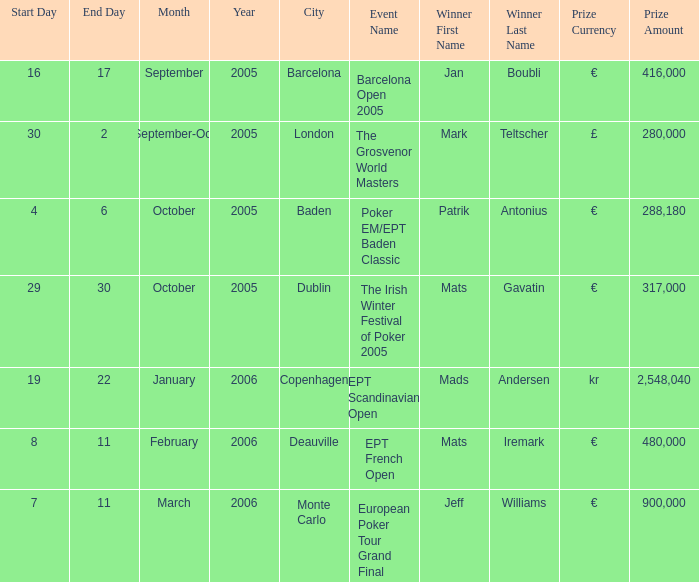Which occurrence awarded a €900,000 reward? European Poker Tour Grand Final. 